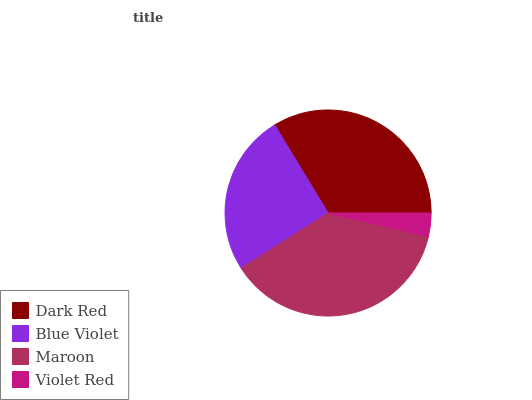Is Violet Red the minimum?
Answer yes or no. Yes. Is Maroon the maximum?
Answer yes or no. Yes. Is Blue Violet the minimum?
Answer yes or no. No. Is Blue Violet the maximum?
Answer yes or no. No. Is Dark Red greater than Blue Violet?
Answer yes or no. Yes. Is Blue Violet less than Dark Red?
Answer yes or no. Yes. Is Blue Violet greater than Dark Red?
Answer yes or no. No. Is Dark Red less than Blue Violet?
Answer yes or no. No. Is Dark Red the high median?
Answer yes or no. Yes. Is Blue Violet the low median?
Answer yes or no. Yes. Is Blue Violet the high median?
Answer yes or no. No. Is Dark Red the low median?
Answer yes or no. No. 